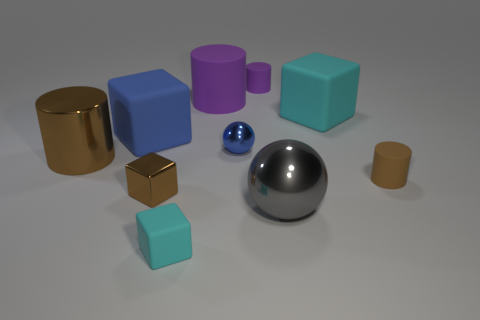Subtract all tiny cyan rubber blocks. How many blocks are left? 3 Subtract 2 cylinders. How many cylinders are left? 2 Subtract all brown blocks. How many blocks are left? 3 Subtract all green cylinders. Subtract all cyan spheres. How many cylinders are left? 4 Subtract all spheres. How many objects are left? 8 Subtract all brown metal blocks. Subtract all metallic blocks. How many objects are left? 8 Add 8 tiny brown metal things. How many tiny brown metal things are left? 9 Add 8 small brown cylinders. How many small brown cylinders exist? 9 Subtract 0 yellow cubes. How many objects are left? 10 